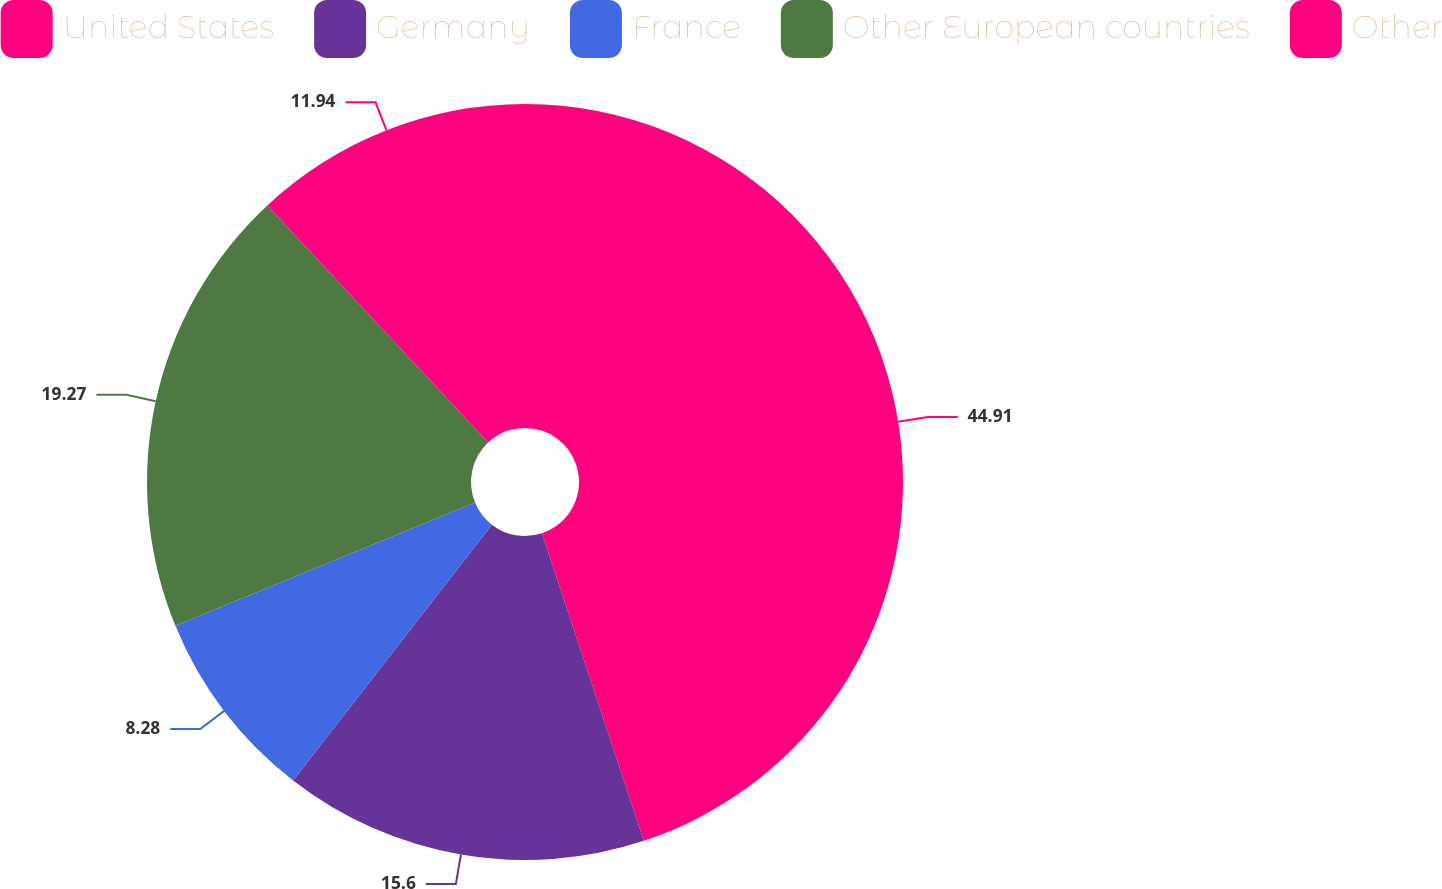Convert chart. <chart><loc_0><loc_0><loc_500><loc_500><pie_chart><fcel>United States<fcel>Germany<fcel>France<fcel>Other European countries<fcel>Other<nl><fcel>44.91%<fcel>15.6%<fcel>8.28%<fcel>19.27%<fcel>11.94%<nl></chart> 